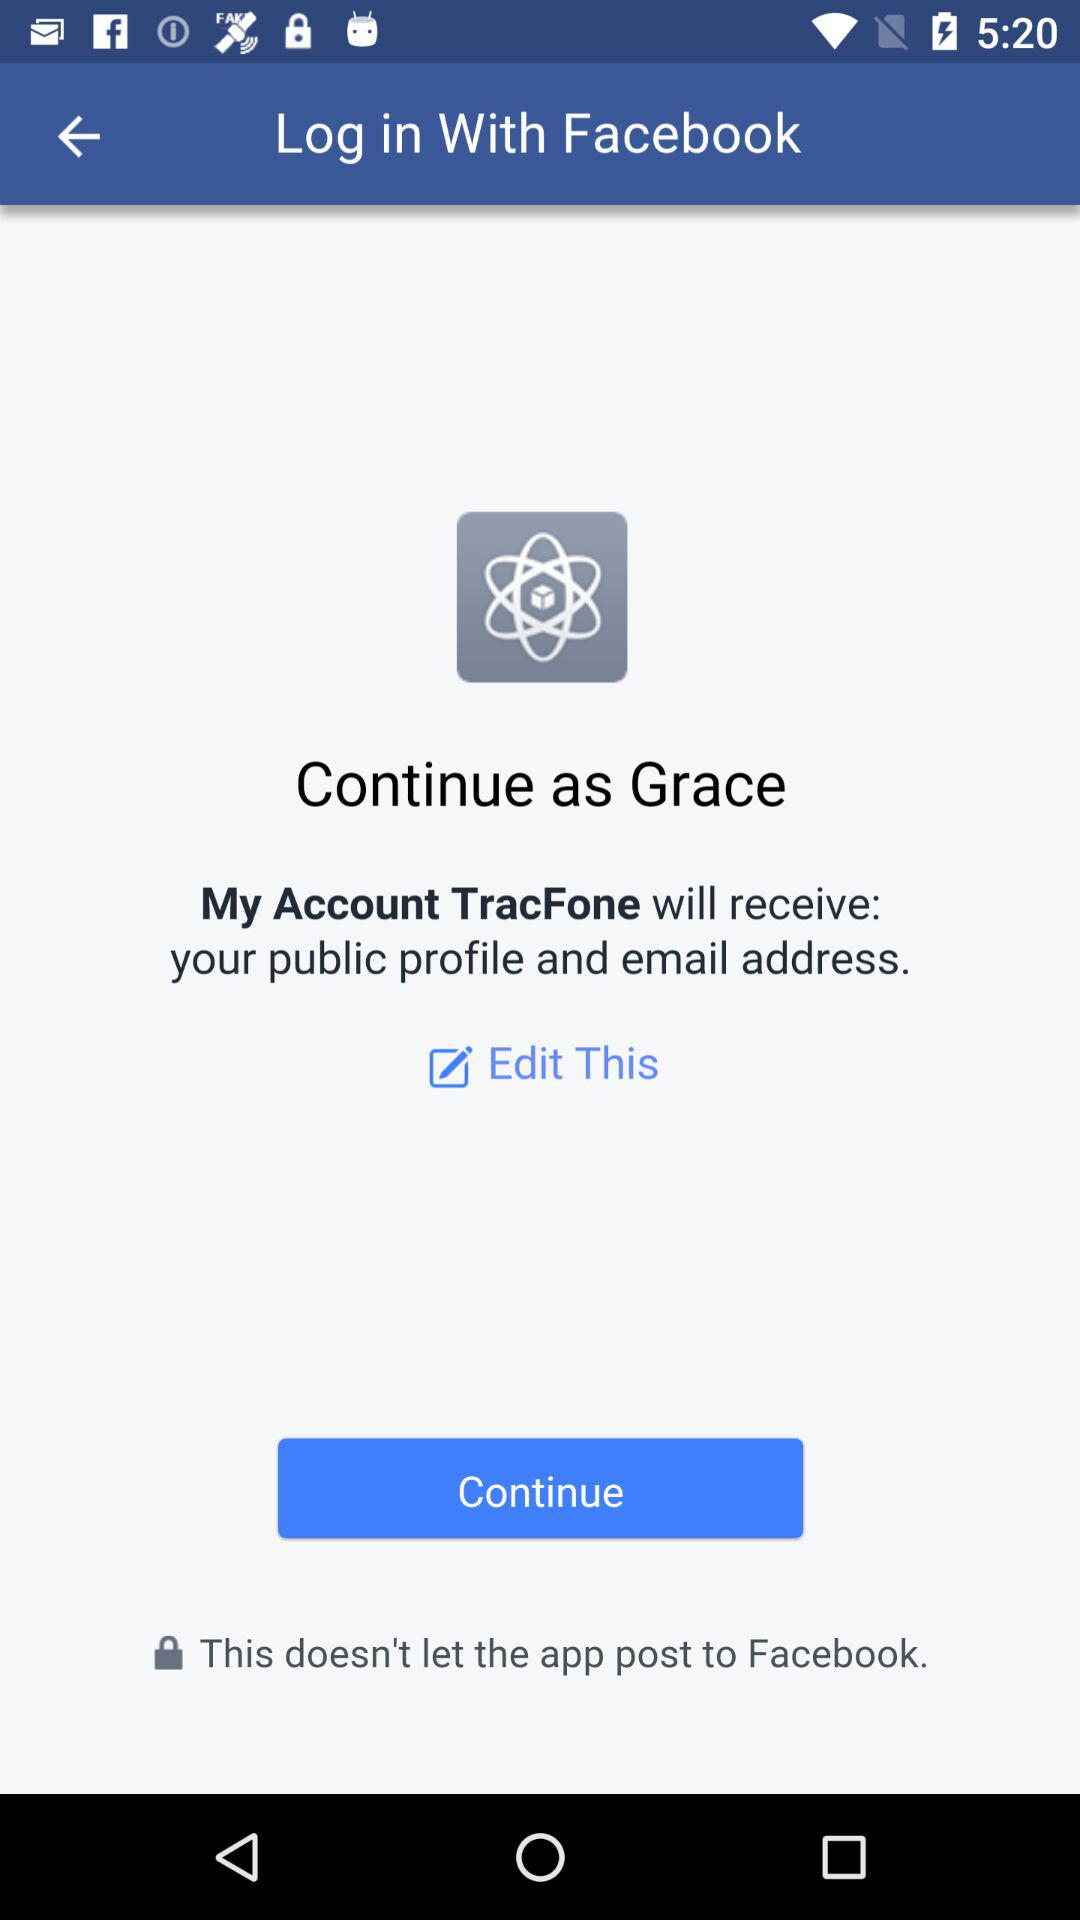Who is continuing?
When the provided information is insufficient, respond with <no answer>. <no answer> 